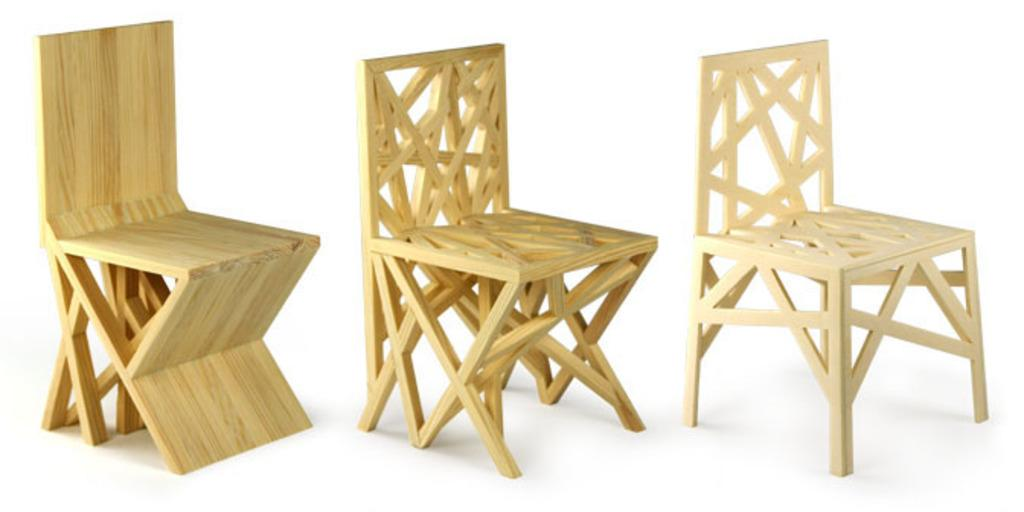What type of chairs are present in the image? There are wooden chairs in the image. Can you describe the material of the chairs? The chairs are made of wood. How many chairs can be seen in the image? The image shows multiple wooden chairs. Is there a girl sitting on one of the chairs in the image? There is no mention of a girl or anyone sitting on the chairs in the provided facts, so we cannot determine if a girl is present in the image. 